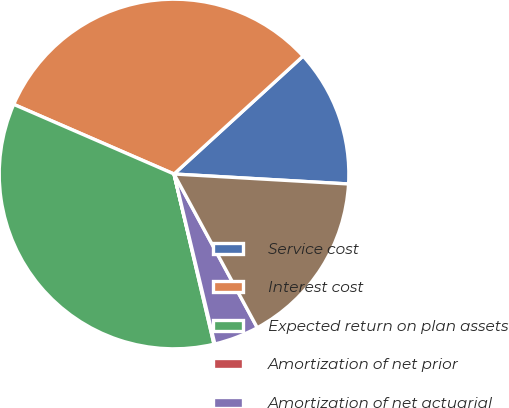Convert chart to OTSL. <chart><loc_0><loc_0><loc_500><loc_500><pie_chart><fcel>Service cost<fcel>Interest cost<fcel>Expected return on plan assets<fcel>Amortization of net prior<fcel>Amortization of net actuarial<fcel>Net periodic benefit cost<nl><fcel>12.69%<fcel>31.69%<fcel>35.19%<fcel>0.08%<fcel>4.15%<fcel>16.19%<nl></chart> 